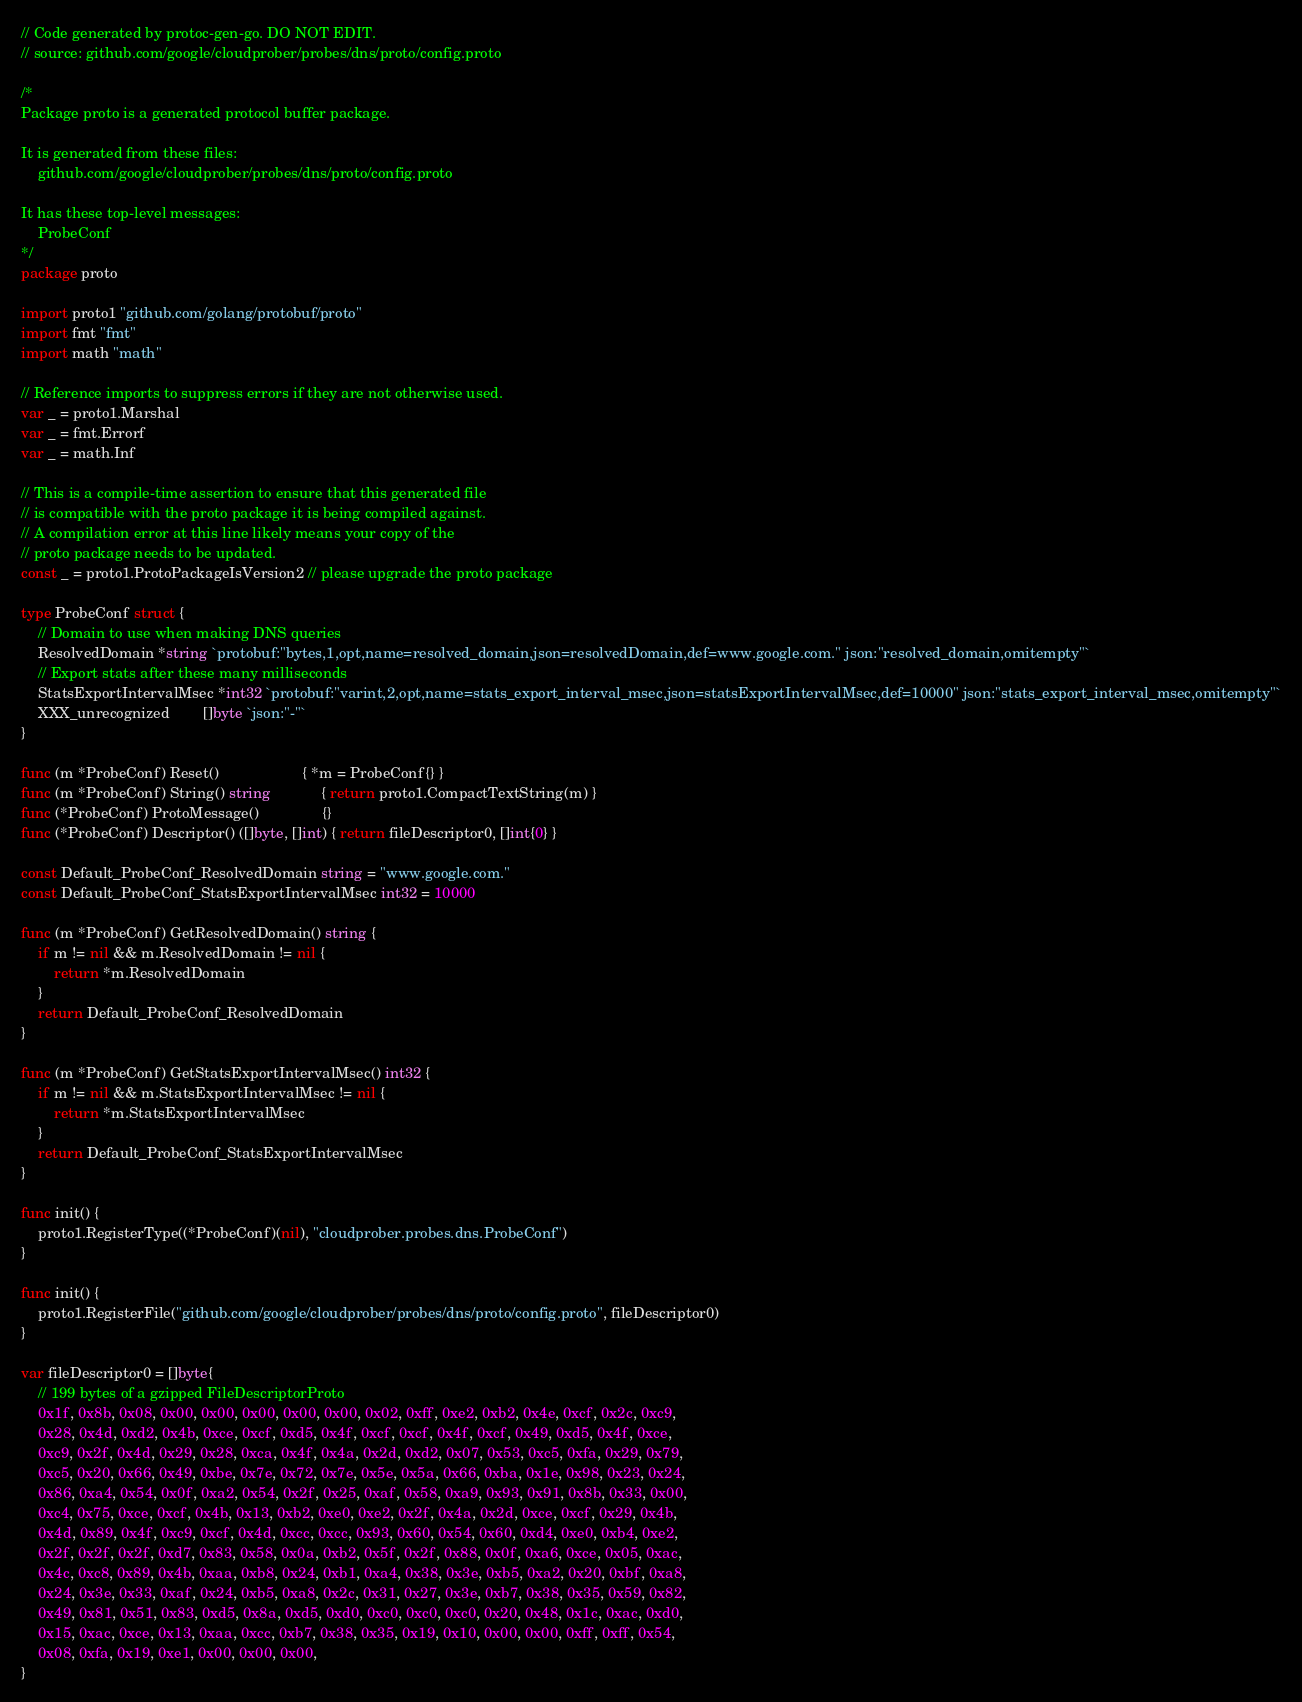<code> <loc_0><loc_0><loc_500><loc_500><_Go_>// Code generated by protoc-gen-go. DO NOT EDIT.
// source: github.com/google/cloudprober/probes/dns/proto/config.proto

/*
Package proto is a generated protocol buffer package.

It is generated from these files:
	github.com/google/cloudprober/probes/dns/proto/config.proto

It has these top-level messages:
	ProbeConf
*/
package proto

import proto1 "github.com/golang/protobuf/proto"
import fmt "fmt"
import math "math"

// Reference imports to suppress errors if they are not otherwise used.
var _ = proto1.Marshal
var _ = fmt.Errorf
var _ = math.Inf

// This is a compile-time assertion to ensure that this generated file
// is compatible with the proto package it is being compiled against.
// A compilation error at this line likely means your copy of the
// proto package needs to be updated.
const _ = proto1.ProtoPackageIsVersion2 // please upgrade the proto package

type ProbeConf struct {
	// Domain to use when making DNS queries
	ResolvedDomain *string `protobuf:"bytes,1,opt,name=resolved_domain,json=resolvedDomain,def=www.google.com." json:"resolved_domain,omitempty"`
	// Export stats after these many milliseconds
	StatsExportIntervalMsec *int32 `protobuf:"varint,2,opt,name=stats_export_interval_msec,json=statsExportIntervalMsec,def=10000" json:"stats_export_interval_msec,omitempty"`
	XXX_unrecognized        []byte `json:"-"`
}

func (m *ProbeConf) Reset()                    { *m = ProbeConf{} }
func (m *ProbeConf) String() string            { return proto1.CompactTextString(m) }
func (*ProbeConf) ProtoMessage()               {}
func (*ProbeConf) Descriptor() ([]byte, []int) { return fileDescriptor0, []int{0} }

const Default_ProbeConf_ResolvedDomain string = "www.google.com."
const Default_ProbeConf_StatsExportIntervalMsec int32 = 10000

func (m *ProbeConf) GetResolvedDomain() string {
	if m != nil && m.ResolvedDomain != nil {
		return *m.ResolvedDomain
	}
	return Default_ProbeConf_ResolvedDomain
}

func (m *ProbeConf) GetStatsExportIntervalMsec() int32 {
	if m != nil && m.StatsExportIntervalMsec != nil {
		return *m.StatsExportIntervalMsec
	}
	return Default_ProbeConf_StatsExportIntervalMsec
}

func init() {
	proto1.RegisterType((*ProbeConf)(nil), "cloudprober.probes.dns.ProbeConf")
}

func init() {
	proto1.RegisterFile("github.com/google/cloudprober/probes/dns/proto/config.proto", fileDescriptor0)
}

var fileDescriptor0 = []byte{
	// 199 bytes of a gzipped FileDescriptorProto
	0x1f, 0x8b, 0x08, 0x00, 0x00, 0x00, 0x00, 0x00, 0x02, 0xff, 0xe2, 0xb2, 0x4e, 0xcf, 0x2c, 0xc9,
	0x28, 0x4d, 0xd2, 0x4b, 0xce, 0xcf, 0xd5, 0x4f, 0xcf, 0xcf, 0x4f, 0xcf, 0x49, 0xd5, 0x4f, 0xce,
	0xc9, 0x2f, 0x4d, 0x29, 0x28, 0xca, 0x4f, 0x4a, 0x2d, 0xd2, 0x07, 0x53, 0xc5, 0xfa, 0x29, 0x79,
	0xc5, 0x20, 0x66, 0x49, 0xbe, 0x7e, 0x72, 0x7e, 0x5e, 0x5a, 0x66, 0xba, 0x1e, 0x98, 0x23, 0x24,
	0x86, 0xa4, 0x54, 0x0f, 0xa2, 0x54, 0x2f, 0x25, 0xaf, 0x58, 0xa9, 0x93, 0x91, 0x8b, 0x33, 0x00,
	0xc4, 0x75, 0xce, 0xcf, 0x4b, 0x13, 0xb2, 0xe0, 0xe2, 0x2f, 0x4a, 0x2d, 0xce, 0xcf, 0x29, 0x4b,
	0x4d, 0x89, 0x4f, 0xc9, 0xcf, 0x4d, 0xcc, 0xcc, 0x93, 0x60, 0x54, 0x60, 0xd4, 0xe0, 0xb4, 0xe2,
	0x2f, 0x2f, 0x2f, 0xd7, 0x83, 0x58, 0x0a, 0xb2, 0x5f, 0x2f, 0x88, 0x0f, 0xa6, 0xce, 0x05, 0xac,
	0x4c, 0xc8, 0x89, 0x4b, 0xaa, 0xb8, 0x24, 0xb1, 0xa4, 0x38, 0x3e, 0xb5, 0xa2, 0x20, 0xbf, 0xa8,
	0x24, 0x3e, 0x33, 0xaf, 0x24, 0xb5, 0xa8, 0x2c, 0x31, 0x27, 0x3e, 0xb7, 0x38, 0x35, 0x59, 0x82,
	0x49, 0x81, 0x51, 0x83, 0xd5, 0x8a, 0xd5, 0xd0, 0xc0, 0xc0, 0xc0, 0x20, 0x48, 0x1c, 0xac, 0xd0,
	0x15, 0xac, 0xce, 0x13, 0xaa, 0xcc, 0xb7, 0x38, 0x35, 0x19, 0x10, 0x00, 0x00, 0xff, 0xff, 0x54,
	0x08, 0xfa, 0x19, 0xe1, 0x00, 0x00, 0x00,
}
</code> 